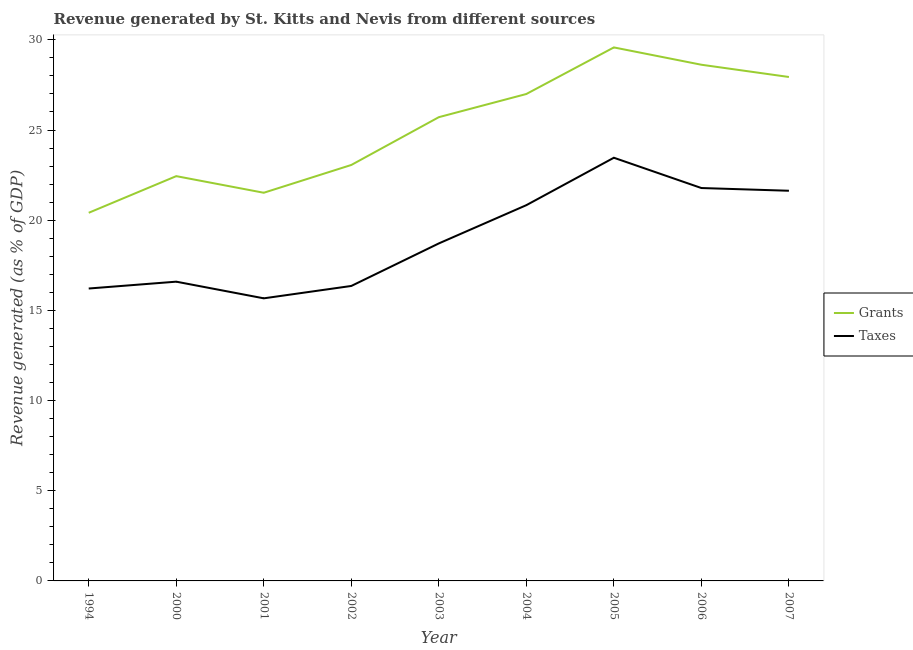How many different coloured lines are there?
Give a very brief answer. 2. Does the line corresponding to revenue generated by grants intersect with the line corresponding to revenue generated by taxes?
Ensure brevity in your answer.  No. Is the number of lines equal to the number of legend labels?
Keep it short and to the point. Yes. What is the revenue generated by grants in 2004?
Offer a very short reply. 27. Across all years, what is the maximum revenue generated by grants?
Offer a very short reply. 29.58. Across all years, what is the minimum revenue generated by grants?
Provide a short and direct response. 20.41. In which year was the revenue generated by grants maximum?
Keep it short and to the point. 2005. What is the total revenue generated by taxes in the graph?
Your response must be concise. 171.25. What is the difference between the revenue generated by taxes in 2005 and that in 2006?
Give a very brief answer. 1.68. What is the difference between the revenue generated by grants in 2003 and the revenue generated by taxes in 2005?
Provide a short and direct response. 2.25. What is the average revenue generated by grants per year?
Your answer should be very brief. 25.14. In the year 2003, what is the difference between the revenue generated by grants and revenue generated by taxes?
Your response must be concise. 7. What is the ratio of the revenue generated by grants in 2003 to that in 2004?
Keep it short and to the point. 0.95. What is the difference between the highest and the second highest revenue generated by grants?
Offer a very short reply. 0.96. What is the difference between the highest and the lowest revenue generated by taxes?
Your answer should be compact. 7.8. Is the sum of the revenue generated by taxes in 1994 and 2002 greater than the maximum revenue generated by grants across all years?
Offer a very short reply. Yes. Is the revenue generated by taxes strictly greater than the revenue generated by grants over the years?
Ensure brevity in your answer.  No. Is the revenue generated by taxes strictly less than the revenue generated by grants over the years?
Your answer should be very brief. Yes. How many lines are there?
Your response must be concise. 2. What is the difference between two consecutive major ticks on the Y-axis?
Your response must be concise. 5. Are the values on the major ticks of Y-axis written in scientific E-notation?
Your answer should be very brief. No. Does the graph contain any zero values?
Keep it short and to the point. No. Does the graph contain grids?
Give a very brief answer. No. How are the legend labels stacked?
Ensure brevity in your answer.  Vertical. What is the title of the graph?
Your answer should be very brief. Revenue generated by St. Kitts and Nevis from different sources. What is the label or title of the X-axis?
Make the answer very short. Year. What is the label or title of the Y-axis?
Provide a succinct answer. Revenue generated (as % of GDP). What is the Revenue generated (as % of GDP) in Grants in 1994?
Provide a short and direct response. 20.41. What is the Revenue generated (as % of GDP) of Taxes in 1994?
Keep it short and to the point. 16.21. What is the Revenue generated (as % of GDP) of Grants in 2000?
Keep it short and to the point. 22.44. What is the Revenue generated (as % of GDP) of Taxes in 2000?
Provide a short and direct response. 16.59. What is the Revenue generated (as % of GDP) of Grants in 2001?
Keep it short and to the point. 21.52. What is the Revenue generated (as % of GDP) of Taxes in 2001?
Make the answer very short. 15.67. What is the Revenue generated (as % of GDP) in Grants in 2002?
Keep it short and to the point. 23.06. What is the Revenue generated (as % of GDP) in Taxes in 2002?
Your answer should be very brief. 16.35. What is the Revenue generated (as % of GDP) in Grants in 2003?
Offer a very short reply. 25.71. What is the Revenue generated (as % of GDP) in Taxes in 2003?
Keep it short and to the point. 18.71. What is the Revenue generated (as % of GDP) of Grants in 2004?
Provide a short and direct response. 27. What is the Revenue generated (as % of GDP) in Taxes in 2004?
Keep it short and to the point. 20.83. What is the Revenue generated (as % of GDP) in Grants in 2005?
Your response must be concise. 29.58. What is the Revenue generated (as % of GDP) of Taxes in 2005?
Make the answer very short. 23.46. What is the Revenue generated (as % of GDP) of Grants in 2006?
Keep it short and to the point. 28.62. What is the Revenue generated (as % of GDP) of Taxes in 2006?
Offer a terse response. 21.78. What is the Revenue generated (as % of GDP) of Grants in 2007?
Keep it short and to the point. 27.94. What is the Revenue generated (as % of GDP) in Taxes in 2007?
Make the answer very short. 21.63. Across all years, what is the maximum Revenue generated (as % of GDP) of Grants?
Provide a short and direct response. 29.58. Across all years, what is the maximum Revenue generated (as % of GDP) in Taxes?
Keep it short and to the point. 23.46. Across all years, what is the minimum Revenue generated (as % of GDP) in Grants?
Ensure brevity in your answer.  20.41. Across all years, what is the minimum Revenue generated (as % of GDP) of Taxes?
Give a very brief answer. 15.67. What is the total Revenue generated (as % of GDP) of Grants in the graph?
Give a very brief answer. 226.29. What is the total Revenue generated (as % of GDP) in Taxes in the graph?
Your answer should be compact. 171.25. What is the difference between the Revenue generated (as % of GDP) in Grants in 1994 and that in 2000?
Your response must be concise. -2.03. What is the difference between the Revenue generated (as % of GDP) of Taxes in 1994 and that in 2000?
Ensure brevity in your answer.  -0.38. What is the difference between the Revenue generated (as % of GDP) of Grants in 1994 and that in 2001?
Provide a succinct answer. -1.11. What is the difference between the Revenue generated (as % of GDP) in Taxes in 1994 and that in 2001?
Offer a terse response. 0.54. What is the difference between the Revenue generated (as % of GDP) in Grants in 1994 and that in 2002?
Your answer should be very brief. -2.65. What is the difference between the Revenue generated (as % of GDP) of Taxes in 1994 and that in 2002?
Make the answer very short. -0.14. What is the difference between the Revenue generated (as % of GDP) in Grants in 1994 and that in 2003?
Ensure brevity in your answer.  -5.3. What is the difference between the Revenue generated (as % of GDP) in Grants in 1994 and that in 2004?
Ensure brevity in your answer.  -6.59. What is the difference between the Revenue generated (as % of GDP) in Taxes in 1994 and that in 2004?
Offer a very short reply. -4.62. What is the difference between the Revenue generated (as % of GDP) of Grants in 1994 and that in 2005?
Offer a very short reply. -9.17. What is the difference between the Revenue generated (as % of GDP) of Taxes in 1994 and that in 2005?
Make the answer very short. -7.25. What is the difference between the Revenue generated (as % of GDP) of Grants in 1994 and that in 2006?
Offer a very short reply. -8.21. What is the difference between the Revenue generated (as % of GDP) of Taxes in 1994 and that in 2006?
Offer a terse response. -5.57. What is the difference between the Revenue generated (as % of GDP) of Grants in 1994 and that in 2007?
Ensure brevity in your answer.  -7.53. What is the difference between the Revenue generated (as % of GDP) of Taxes in 1994 and that in 2007?
Make the answer very short. -5.42. What is the difference between the Revenue generated (as % of GDP) in Grants in 2000 and that in 2001?
Your response must be concise. 0.92. What is the difference between the Revenue generated (as % of GDP) in Taxes in 2000 and that in 2001?
Give a very brief answer. 0.92. What is the difference between the Revenue generated (as % of GDP) in Grants in 2000 and that in 2002?
Your response must be concise. -0.62. What is the difference between the Revenue generated (as % of GDP) in Taxes in 2000 and that in 2002?
Your answer should be very brief. 0.24. What is the difference between the Revenue generated (as % of GDP) in Grants in 2000 and that in 2003?
Provide a short and direct response. -3.27. What is the difference between the Revenue generated (as % of GDP) in Taxes in 2000 and that in 2003?
Ensure brevity in your answer.  -2.12. What is the difference between the Revenue generated (as % of GDP) of Grants in 2000 and that in 2004?
Your answer should be compact. -4.55. What is the difference between the Revenue generated (as % of GDP) of Taxes in 2000 and that in 2004?
Offer a terse response. -4.24. What is the difference between the Revenue generated (as % of GDP) in Grants in 2000 and that in 2005?
Your answer should be compact. -7.14. What is the difference between the Revenue generated (as % of GDP) in Taxes in 2000 and that in 2005?
Make the answer very short. -6.87. What is the difference between the Revenue generated (as % of GDP) in Grants in 2000 and that in 2006?
Make the answer very short. -6.18. What is the difference between the Revenue generated (as % of GDP) of Taxes in 2000 and that in 2006?
Make the answer very short. -5.19. What is the difference between the Revenue generated (as % of GDP) of Grants in 2000 and that in 2007?
Offer a terse response. -5.5. What is the difference between the Revenue generated (as % of GDP) of Taxes in 2000 and that in 2007?
Your answer should be very brief. -5.04. What is the difference between the Revenue generated (as % of GDP) of Grants in 2001 and that in 2002?
Offer a terse response. -1.54. What is the difference between the Revenue generated (as % of GDP) of Taxes in 2001 and that in 2002?
Your answer should be compact. -0.69. What is the difference between the Revenue generated (as % of GDP) in Grants in 2001 and that in 2003?
Provide a succinct answer. -4.19. What is the difference between the Revenue generated (as % of GDP) of Taxes in 2001 and that in 2003?
Your response must be concise. -3.04. What is the difference between the Revenue generated (as % of GDP) in Grants in 2001 and that in 2004?
Keep it short and to the point. -5.48. What is the difference between the Revenue generated (as % of GDP) of Taxes in 2001 and that in 2004?
Ensure brevity in your answer.  -5.17. What is the difference between the Revenue generated (as % of GDP) of Grants in 2001 and that in 2005?
Your answer should be compact. -8.06. What is the difference between the Revenue generated (as % of GDP) in Taxes in 2001 and that in 2005?
Your response must be concise. -7.8. What is the difference between the Revenue generated (as % of GDP) in Grants in 2001 and that in 2006?
Ensure brevity in your answer.  -7.1. What is the difference between the Revenue generated (as % of GDP) in Taxes in 2001 and that in 2006?
Provide a succinct answer. -6.12. What is the difference between the Revenue generated (as % of GDP) in Grants in 2001 and that in 2007?
Keep it short and to the point. -6.42. What is the difference between the Revenue generated (as % of GDP) in Taxes in 2001 and that in 2007?
Offer a very short reply. -5.96. What is the difference between the Revenue generated (as % of GDP) in Grants in 2002 and that in 2003?
Ensure brevity in your answer.  -2.65. What is the difference between the Revenue generated (as % of GDP) in Taxes in 2002 and that in 2003?
Your answer should be compact. -2.36. What is the difference between the Revenue generated (as % of GDP) of Grants in 2002 and that in 2004?
Your response must be concise. -3.94. What is the difference between the Revenue generated (as % of GDP) in Taxes in 2002 and that in 2004?
Offer a very short reply. -4.48. What is the difference between the Revenue generated (as % of GDP) of Grants in 2002 and that in 2005?
Offer a very short reply. -6.52. What is the difference between the Revenue generated (as % of GDP) of Taxes in 2002 and that in 2005?
Your response must be concise. -7.11. What is the difference between the Revenue generated (as % of GDP) in Grants in 2002 and that in 2006?
Keep it short and to the point. -5.56. What is the difference between the Revenue generated (as % of GDP) in Taxes in 2002 and that in 2006?
Provide a short and direct response. -5.43. What is the difference between the Revenue generated (as % of GDP) of Grants in 2002 and that in 2007?
Your answer should be very brief. -4.88. What is the difference between the Revenue generated (as % of GDP) in Taxes in 2002 and that in 2007?
Provide a succinct answer. -5.28. What is the difference between the Revenue generated (as % of GDP) of Grants in 2003 and that in 2004?
Provide a succinct answer. -1.28. What is the difference between the Revenue generated (as % of GDP) of Taxes in 2003 and that in 2004?
Offer a terse response. -2.12. What is the difference between the Revenue generated (as % of GDP) of Grants in 2003 and that in 2005?
Provide a short and direct response. -3.87. What is the difference between the Revenue generated (as % of GDP) in Taxes in 2003 and that in 2005?
Offer a terse response. -4.75. What is the difference between the Revenue generated (as % of GDP) of Grants in 2003 and that in 2006?
Ensure brevity in your answer.  -2.91. What is the difference between the Revenue generated (as % of GDP) in Taxes in 2003 and that in 2006?
Offer a terse response. -3.07. What is the difference between the Revenue generated (as % of GDP) of Grants in 2003 and that in 2007?
Offer a terse response. -2.23. What is the difference between the Revenue generated (as % of GDP) in Taxes in 2003 and that in 2007?
Ensure brevity in your answer.  -2.92. What is the difference between the Revenue generated (as % of GDP) in Grants in 2004 and that in 2005?
Provide a short and direct response. -2.58. What is the difference between the Revenue generated (as % of GDP) in Taxes in 2004 and that in 2005?
Your response must be concise. -2.63. What is the difference between the Revenue generated (as % of GDP) of Grants in 2004 and that in 2006?
Ensure brevity in your answer.  -1.62. What is the difference between the Revenue generated (as % of GDP) of Taxes in 2004 and that in 2006?
Provide a short and direct response. -0.95. What is the difference between the Revenue generated (as % of GDP) of Grants in 2004 and that in 2007?
Keep it short and to the point. -0.94. What is the difference between the Revenue generated (as % of GDP) of Taxes in 2004 and that in 2007?
Provide a short and direct response. -0.8. What is the difference between the Revenue generated (as % of GDP) in Grants in 2005 and that in 2006?
Provide a short and direct response. 0.96. What is the difference between the Revenue generated (as % of GDP) of Taxes in 2005 and that in 2006?
Offer a terse response. 1.68. What is the difference between the Revenue generated (as % of GDP) of Grants in 2005 and that in 2007?
Provide a short and direct response. 1.64. What is the difference between the Revenue generated (as % of GDP) in Taxes in 2005 and that in 2007?
Offer a very short reply. 1.83. What is the difference between the Revenue generated (as % of GDP) of Grants in 2006 and that in 2007?
Give a very brief answer. 0.68. What is the difference between the Revenue generated (as % of GDP) in Taxes in 2006 and that in 2007?
Offer a terse response. 0.15. What is the difference between the Revenue generated (as % of GDP) in Grants in 1994 and the Revenue generated (as % of GDP) in Taxes in 2000?
Give a very brief answer. 3.82. What is the difference between the Revenue generated (as % of GDP) in Grants in 1994 and the Revenue generated (as % of GDP) in Taxes in 2001?
Your answer should be very brief. 4.74. What is the difference between the Revenue generated (as % of GDP) of Grants in 1994 and the Revenue generated (as % of GDP) of Taxes in 2002?
Ensure brevity in your answer.  4.06. What is the difference between the Revenue generated (as % of GDP) of Grants in 1994 and the Revenue generated (as % of GDP) of Taxes in 2003?
Provide a succinct answer. 1.7. What is the difference between the Revenue generated (as % of GDP) in Grants in 1994 and the Revenue generated (as % of GDP) in Taxes in 2004?
Keep it short and to the point. -0.42. What is the difference between the Revenue generated (as % of GDP) in Grants in 1994 and the Revenue generated (as % of GDP) in Taxes in 2005?
Ensure brevity in your answer.  -3.05. What is the difference between the Revenue generated (as % of GDP) of Grants in 1994 and the Revenue generated (as % of GDP) of Taxes in 2006?
Your response must be concise. -1.37. What is the difference between the Revenue generated (as % of GDP) of Grants in 1994 and the Revenue generated (as % of GDP) of Taxes in 2007?
Make the answer very short. -1.22. What is the difference between the Revenue generated (as % of GDP) in Grants in 2000 and the Revenue generated (as % of GDP) in Taxes in 2001?
Your answer should be very brief. 6.77. What is the difference between the Revenue generated (as % of GDP) of Grants in 2000 and the Revenue generated (as % of GDP) of Taxes in 2002?
Give a very brief answer. 6.09. What is the difference between the Revenue generated (as % of GDP) in Grants in 2000 and the Revenue generated (as % of GDP) in Taxes in 2003?
Your answer should be compact. 3.73. What is the difference between the Revenue generated (as % of GDP) in Grants in 2000 and the Revenue generated (as % of GDP) in Taxes in 2004?
Keep it short and to the point. 1.61. What is the difference between the Revenue generated (as % of GDP) of Grants in 2000 and the Revenue generated (as % of GDP) of Taxes in 2005?
Provide a short and direct response. -1.02. What is the difference between the Revenue generated (as % of GDP) of Grants in 2000 and the Revenue generated (as % of GDP) of Taxes in 2006?
Your answer should be very brief. 0.66. What is the difference between the Revenue generated (as % of GDP) of Grants in 2000 and the Revenue generated (as % of GDP) of Taxes in 2007?
Give a very brief answer. 0.81. What is the difference between the Revenue generated (as % of GDP) in Grants in 2001 and the Revenue generated (as % of GDP) in Taxes in 2002?
Provide a short and direct response. 5.17. What is the difference between the Revenue generated (as % of GDP) in Grants in 2001 and the Revenue generated (as % of GDP) in Taxes in 2003?
Make the answer very short. 2.81. What is the difference between the Revenue generated (as % of GDP) of Grants in 2001 and the Revenue generated (as % of GDP) of Taxes in 2004?
Your answer should be compact. 0.69. What is the difference between the Revenue generated (as % of GDP) of Grants in 2001 and the Revenue generated (as % of GDP) of Taxes in 2005?
Offer a very short reply. -1.94. What is the difference between the Revenue generated (as % of GDP) in Grants in 2001 and the Revenue generated (as % of GDP) in Taxes in 2006?
Your response must be concise. -0.26. What is the difference between the Revenue generated (as % of GDP) of Grants in 2001 and the Revenue generated (as % of GDP) of Taxes in 2007?
Offer a very short reply. -0.11. What is the difference between the Revenue generated (as % of GDP) of Grants in 2002 and the Revenue generated (as % of GDP) of Taxes in 2003?
Provide a succinct answer. 4.35. What is the difference between the Revenue generated (as % of GDP) in Grants in 2002 and the Revenue generated (as % of GDP) in Taxes in 2004?
Your answer should be very brief. 2.23. What is the difference between the Revenue generated (as % of GDP) in Grants in 2002 and the Revenue generated (as % of GDP) in Taxes in 2005?
Provide a succinct answer. -0.4. What is the difference between the Revenue generated (as % of GDP) of Grants in 2002 and the Revenue generated (as % of GDP) of Taxes in 2006?
Make the answer very short. 1.28. What is the difference between the Revenue generated (as % of GDP) of Grants in 2002 and the Revenue generated (as % of GDP) of Taxes in 2007?
Ensure brevity in your answer.  1.43. What is the difference between the Revenue generated (as % of GDP) in Grants in 2003 and the Revenue generated (as % of GDP) in Taxes in 2004?
Keep it short and to the point. 4.88. What is the difference between the Revenue generated (as % of GDP) in Grants in 2003 and the Revenue generated (as % of GDP) in Taxes in 2005?
Your response must be concise. 2.25. What is the difference between the Revenue generated (as % of GDP) in Grants in 2003 and the Revenue generated (as % of GDP) in Taxes in 2006?
Your response must be concise. 3.93. What is the difference between the Revenue generated (as % of GDP) in Grants in 2003 and the Revenue generated (as % of GDP) in Taxes in 2007?
Give a very brief answer. 4.08. What is the difference between the Revenue generated (as % of GDP) in Grants in 2004 and the Revenue generated (as % of GDP) in Taxes in 2005?
Your answer should be compact. 3.53. What is the difference between the Revenue generated (as % of GDP) in Grants in 2004 and the Revenue generated (as % of GDP) in Taxes in 2006?
Give a very brief answer. 5.21. What is the difference between the Revenue generated (as % of GDP) of Grants in 2004 and the Revenue generated (as % of GDP) of Taxes in 2007?
Ensure brevity in your answer.  5.36. What is the difference between the Revenue generated (as % of GDP) in Grants in 2005 and the Revenue generated (as % of GDP) in Taxes in 2006?
Your answer should be very brief. 7.8. What is the difference between the Revenue generated (as % of GDP) of Grants in 2005 and the Revenue generated (as % of GDP) of Taxes in 2007?
Ensure brevity in your answer.  7.95. What is the difference between the Revenue generated (as % of GDP) of Grants in 2006 and the Revenue generated (as % of GDP) of Taxes in 2007?
Provide a short and direct response. 6.99. What is the average Revenue generated (as % of GDP) in Grants per year?
Make the answer very short. 25.14. What is the average Revenue generated (as % of GDP) of Taxes per year?
Make the answer very short. 19.03. In the year 1994, what is the difference between the Revenue generated (as % of GDP) in Grants and Revenue generated (as % of GDP) in Taxes?
Your response must be concise. 4.2. In the year 2000, what is the difference between the Revenue generated (as % of GDP) in Grants and Revenue generated (as % of GDP) in Taxes?
Provide a succinct answer. 5.85. In the year 2001, what is the difference between the Revenue generated (as % of GDP) in Grants and Revenue generated (as % of GDP) in Taxes?
Give a very brief answer. 5.85. In the year 2002, what is the difference between the Revenue generated (as % of GDP) in Grants and Revenue generated (as % of GDP) in Taxes?
Your answer should be very brief. 6.71. In the year 2003, what is the difference between the Revenue generated (as % of GDP) in Grants and Revenue generated (as % of GDP) in Taxes?
Your response must be concise. 7. In the year 2004, what is the difference between the Revenue generated (as % of GDP) of Grants and Revenue generated (as % of GDP) of Taxes?
Keep it short and to the point. 6.16. In the year 2005, what is the difference between the Revenue generated (as % of GDP) in Grants and Revenue generated (as % of GDP) in Taxes?
Give a very brief answer. 6.12. In the year 2006, what is the difference between the Revenue generated (as % of GDP) in Grants and Revenue generated (as % of GDP) in Taxes?
Offer a terse response. 6.84. In the year 2007, what is the difference between the Revenue generated (as % of GDP) in Grants and Revenue generated (as % of GDP) in Taxes?
Make the answer very short. 6.31. What is the ratio of the Revenue generated (as % of GDP) of Grants in 1994 to that in 2000?
Offer a very short reply. 0.91. What is the ratio of the Revenue generated (as % of GDP) in Taxes in 1994 to that in 2000?
Offer a very short reply. 0.98. What is the ratio of the Revenue generated (as % of GDP) of Grants in 1994 to that in 2001?
Give a very brief answer. 0.95. What is the ratio of the Revenue generated (as % of GDP) in Taxes in 1994 to that in 2001?
Keep it short and to the point. 1.03. What is the ratio of the Revenue generated (as % of GDP) in Grants in 1994 to that in 2002?
Your response must be concise. 0.89. What is the ratio of the Revenue generated (as % of GDP) in Taxes in 1994 to that in 2002?
Your response must be concise. 0.99. What is the ratio of the Revenue generated (as % of GDP) in Grants in 1994 to that in 2003?
Your answer should be compact. 0.79. What is the ratio of the Revenue generated (as % of GDP) of Taxes in 1994 to that in 2003?
Provide a short and direct response. 0.87. What is the ratio of the Revenue generated (as % of GDP) of Grants in 1994 to that in 2004?
Give a very brief answer. 0.76. What is the ratio of the Revenue generated (as % of GDP) in Taxes in 1994 to that in 2004?
Give a very brief answer. 0.78. What is the ratio of the Revenue generated (as % of GDP) of Grants in 1994 to that in 2005?
Your response must be concise. 0.69. What is the ratio of the Revenue generated (as % of GDP) in Taxes in 1994 to that in 2005?
Keep it short and to the point. 0.69. What is the ratio of the Revenue generated (as % of GDP) of Grants in 1994 to that in 2006?
Your response must be concise. 0.71. What is the ratio of the Revenue generated (as % of GDP) in Taxes in 1994 to that in 2006?
Offer a terse response. 0.74. What is the ratio of the Revenue generated (as % of GDP) of Grants in 1994 to that in 2007?
Make the answer very short. 0.73. What is the ratio of the Revenue generated (as % of GDP) of Taxes in 1994 to that in 2007?
Your response must be concise. 0.75. What is the ratio of the Revenue generated (as % of GDP) in Grants in 2000 to that in 2001?
Ensure brevity in your answer.  1.04. What is the ratio of the Revenue generated (as % of GDP) of Taxes in 2000 to that in 2001?
Your answer should be very brief. 1.06. What is the ratio of the Revenue generated (as % of GDP) of Grants in 2000 to that in 2002?
Make the answer very short. 0.97. What is the ratio of the Revenue generated (as % of GDP) of Taxes in 2000 to that in 2002?
Your answer should be compact. 1.01. What is the ratio of the Revenue generated (as % of GDP) of Grants in 2000 to that in 2003?
Offer a terse response. 0.87. What is the ratio of the Revenue generated (as % of GDP) in Taxes in 2000 to that in 2003?
Provide a short and direct response. 0.89. What is the ratio of the Revenue generated (as % of GDP) of Grants in 2000 to that in 2004?
Your answer should be compact. 0.83. What is the ratio of the Revenue generated (as % of GDP) of Taxes in 2000 to that in 2004?
Provide a short and direct response. 0.8. What is the ratio of the Revenue generated (as % of GDP) of Grants in 2000 to that in 2005?
Ensure brevity in your answer.  0.76. What is the ratio of the Revenue generated (as % of GDP) in Taxes in 2000 to that in 2005?
Offer a terse response. 0.71. What is the ratio of the Revenue generated (as % of GDP) in Grants in 2000 to that in 2006?
Give a very brief answer. 0.78. What is the ratio of the Revenue generated (as % of GDP) of Taxes in 2000 to that in 2006?
Provide a short and direct response. 0.76. What is the ratio of the Revenue generated (as % of GDP) in Grants in 2000 to that in 2007?
Provide a short and direct response. 0.8. What is the ratio of the Revenue generated (as % of GDP) of Taxes in 2000 to that in 2007?
Your answer should be very brief. 0.77. What is the ratio of the Revenue generated (as % of GDP) in Grants in 2001 to that in 2002?
Provide a succinct answer. 0.93. What is the ratio of the Revenue generated (as % of GDP) of Taxes in 2001 to that in 2002?
Keep it short and to the point. 0.96. What is the ratio of the Revenue generated (as % of GDP) in Grants in 2001 to that in 2003?
Make the answer very short. 0.84. What is the ratio of the Revenue generated (as % of GDP) of Taxes in 2001 to that in 2003?
Give a very brief answer. 0.84. What is the ratio of the Revenue generated (as % of GDP) in Grants in 2001 to that in 2004?
Provide a short and direct response. 0.8. What is the ratio of the Revenue generated (as % of GDP) of Taxes in 2001 to that in 2004?
Offer a terse response. 0.75. What is the ratio of the Revenue generated (as % of GDP) in Grants in 2001 to that in 2005?
Give a very brief answer. 0.73. What is the ratio of the Revenue generated (as % of GDP) in Taxes in 2001 to that in 2005?
Provide a short and direct response. 0.67. What is the ratio of the Revenue generated (as % of GDP) in Grants in 2001 to that in 2006?
Your answer should be very brief. 0.75. What is the ratio of the Revenue generated (as % of GDP) in Taxes in 2001 to that in 2006?
Your answer should be very brief. 0.72. What is the ratio of the Revenue generated (as % of GDP) in Grants in 2001 to that in 2007?
Offer a very short reply. 0.77. What is the ratio of the Revenue generated (as % of GDP) in Taxes in 2001 to that in 2007?
Give a very brief answer. 0.72. What is the ratio of the Revenue generated (as % of GDP) of Grants in 2002 to that in 2003?
Give a very brief answer. 0.9. What is the ratio of the Revenue generated (as % of GDP) in Taxes in 2002 to that in 2003?
Your answer should be very brief. 0.87. What is the ratio of the Revenue generated (as % of GDP) of Grants in 2002 to that in 2004?
Provide a short and direct response. 0.85. What is the ratio of the Revenue generated (as % of GDP) in Taxes in 2002 to that in 2004?
Your response must be concise. 0.79. What is the ratio of the Revenue generated (as % of GDP) in Grants in 2002 to that in 2005?
Provide a succinct answer. 0.78. What is the ratio of the Revenue generated (as % of GDP) in Taxes in 2002 to that in 2005?
Keep it short and to the point. 0.7. What is the ratio of the Revenue generated (as % of GDP) in Grants in 2002 to that in 2006?
Keep it short and to the point. 0.81. What is the ratio of the Revenue generated (as % of GDP) of Taxes in 2002 to that in 2006?
Your response must be concise. 0.75. What is the ratio of the Revenue generated (as % of GDP) in Grants in 2002 to that in 2007?
Keep it short and to the point. 0.83. What is the ratio of the Revenue generated (as % of GDP) in Taxes in 2002 to that in 2007?
Offer a terse response. 0.76. What is the ratio of the Revenue generated (as % of GDP) of Grants in 2003 to that in 2004?
Your answer should be compact. 0.95. What is the ratio of the Revenue generated (as % of GDP) of Taxes in 2003 to that in 2004?
Keep it short and to the point. 0.9. What is the ratio of the Revenue generated (as % of GDP) in Grants in 2003 to that in 2005?
Provide a short and direct response. 0.87. What is the ratio of the Revenue generated (as % of GDP) in Taxes in 2003 to that in 2005?
Offer a very short reply. 0.8. What is the ratio of the Revenue generated (as % of GDP) of Grants in 2003 to that in 2006?
Your answer should be compact. 0.9. What is the ratio of the Revenue generated (as % of GDP) in Taxes in 2003 to that in 2006?
Keep it short and to the point. 0.86. What is the ratio of the Revenue generated (as % of GDP) of Grants in 2003 to that in 2007?
Provide a short and direct response. 0.92. What is the ratio of the Revenue generated (as % of GDP) of Taxes in 2003 to that in 2007?
Provide a succinct answer. 0.86. What is the ratio of the Revenue generated (as % of GDP) of Grants in 2004 to that in 2005?
Offer a terse response. 0.91. What is the ratio of the Revenue generated (as % of GDP) in Taxes in 2004 to that in 2005?
Provide a succinct answer. 0.89. What is the ratio of the Revenue generated (as % of GDP) of Grants in 2004 to that in 2006?
Offer a very short reply. 0.94. What is the ratio of the Revenue generated (as % of GDP) in Taxes in 2004 to that in 2006?
Give a very brief answer. 0.96. What is the ratio of the Revenue generated (as % of GDP) in Grants in 2004 to that in 2007?
Provide a succinct answer. 0.97. What is the ratio of the Revenue generated (as % of GDP) of Taxes in 2004 to that in 2007?
Your response must be concise. 0.96. What is the ratio of the Revenue generated (as % of GDP) of Grants in 2005 to that in 2006?
Provide a succinct answer. 1.03. What is the ratio of the Revenue generated (as % of GDP) in Taxes in 2005 to that in 2006?
Your response must be concise. 1.08. What is the ratio of the Revenue generated (as % of GDP) of Grants in 2005 to that in 2007?
Your answer should be compact. 1.06. What is the ratio of the Revenue generated (as % of GDP) in Taxes in 2005 to that in 2007?
Keep it short and to the point. 1.08. What is the ratio of the Revenue generated (as % of GDP) of Grants in 2006 to that in 2007?
Offer a very short reply. 1.02. What is the difference between the highest and the second highest Revenue generated (as % of GDP) of Grants?
Provide a succinct answer. 0.96. What is the difference between the highest and the second highest Revenue generated (as % of GDP) of Taxes?
Your answer should be compact. 1.68. What is the difference between the highest and the lowest Revenue generated (as % of GDP) of Grants?
Provide a short and direct response. 9.17. What is the difference between the highest and the lowest Revenue generated (as % of GDP) in Taxes?
Keep it short and to the point. 7.8. 